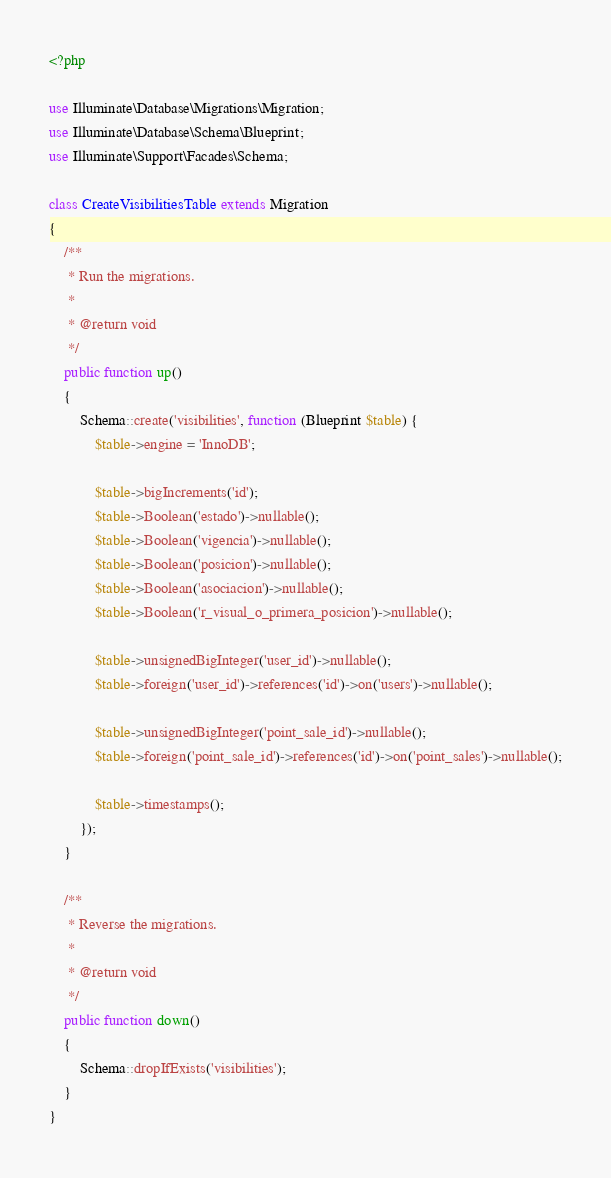<code> <loc_0><loc_0><loc_500><loc_500><_PHP_><?php

use Illuminate\Database\Migrations\Migration;
use Illuminate\Database\Schema\Blueprint;
use Illuminate\Support\Facades\Schema;

class CreateVisibilitiesTable extends Migration
{
    /**
     * Run the migrations.
     *
     * @return void
     */
    public function up()
    {
        Schema::create('visibilities', function (Blueprint $table) {
            $table->engine = 'InnoDB';
            
            $table->bigIncrements('id'); 
            $table->Boolean('estado')->nullable();
            $table->Boolean('vigencia')->nullable();
            $table->Boolean('posicion')->nullable();
            $table->Boolean('asociacion')->nullable();
            $table->Boolean('r_visual_o_primera_posicion')->nullable();
            
            $table->unsignedBigInteger('user_id')->nullable();
            $table->foreign('user_id')->references('id')->on('users')->nullable();

            $table->unsignedBigInteger('point_sale_id')->nullable();
            $table->foreign('point_sale_id')->references('id')->on('point_sales')->nullable();

            $table->timestamps();
        });
    }

    /**
     * Reverse the migrations.
     *
     * @return void
     */
    public function down()
    {
        Schema::dropIfExists('visibilities');
    }
}
</code> 